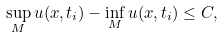<formula> <loc_0><loc_0><loc_500><loc_500>\sup _ { M } u ( x , t _ { i } ) - \inf _ { M } u ( x , t _ { i } ) \leq C ,</formula> 